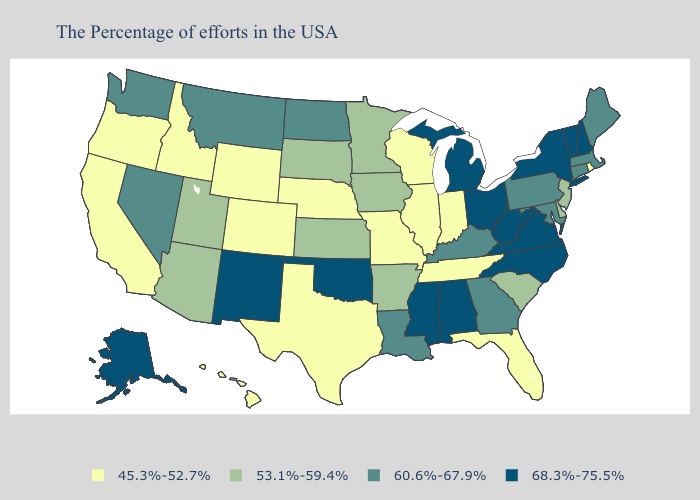How many symbols are there in the legend?
Answer briefly. 4. Does the map have missing data?
Give a very brief answer. No. What is the highest value in states that border North Dakota?
Answer briefly. 60.6%-67.9%. Which states have the lowest value in the South?
Quick response, please. Florida, Tennessee, Texas. What is the highest value in states that border Delaware?
Quick response, please. 60.6%-67.9%. Does the map have missing data?
Concise answer only. No. Among the states that border Tennessee , which have the highest value?
Write a very short answer. Virginia, North Carolina, Alabama, Mississippi. What is the lowest value in the South?
Answer briefly. 45.3%-52.7%. What is the value of Mississippi?
Keep it brief. 68.3%-75.5%. What is the lowest value in states that border Iowa?
Short answer required. 45.3%-52.7%. What is the value of Colorado?
Answer briefly. 45.3%-52.7%. Which states have the highest value in the USA?
Write a very short answer. New Hampshire, Vermont, New York, Virginia, North Carolina, West Virginia, Ohio, Michigan, Alabama, Mississippi, Oklahoma, New Mexico, Alaska. What is the value of Wisconsin?
Keep it brief. 45.3%-52.7%. What is the value of Nebraska?
Quick response, please. 45.3%-52.7%. What is the lowest value in states that border Oregon?
Be succinct. 45.3%-52.7%. 